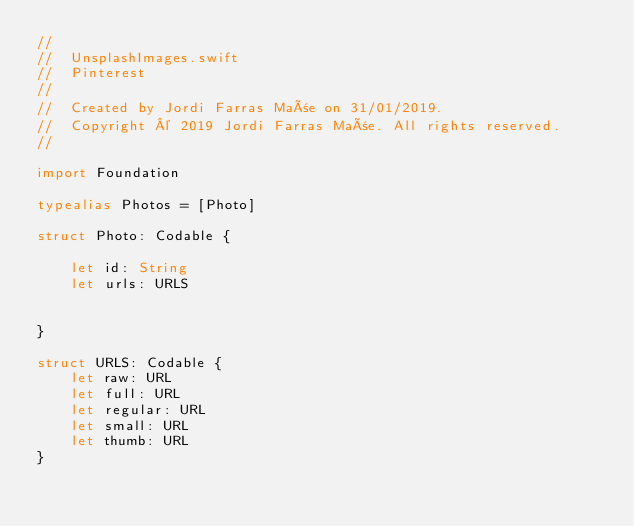<code> <loc_0><loc_0><loc_500><loc_500><_Swift_>//
//  UnsplashImages.swift
//  Pinterest
//
//  Created by Jordi Farras Mañe on 31/01/2019.
//  Copyright © 2019 Jordi Farras Mañe. All rights reserved.
//

import Foundation

typealias Photos = [Photo]

struct Photo: Codable {
    
    let id: String
    let urls: URLS
    
    
}

struct URLS: Codable {
    let raw: URL
    let full: URL
    let regular: URL
    let small: URL
    let thumb: URL
}
</code> 